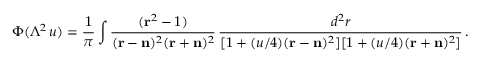Convert formula to latex. <formula><loc_0><loc_0><loc_500><loc_500>\Phi ( \Lambda ^ { 2 } \, u ) = { \frac { 1 } { \pi } } \int { \frac { ( { r } ^ { 2 } - 1 ) } { ( { r } - { n } ) ^ { 2 } ( { r } + { n } ) ^ { 2 } } } \, { \frac { d ^ { 2 } r } { [ 1 + ( u / 4 ) ( { r } - { n } ) ^ { 2 } ] [ 1 + ( u / 4 ) ( { r } + { n } ) ^ { 2 } ] } } \, .</formula> 